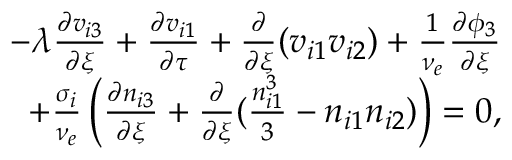Convert formula to latex. <formula><loc_0><loc_0><loc_500><loc_500>\begin{array} { r } { - \lambda \frac { \partial v _ { i 3 } } { \partial \xi } + \frac { \partial v _ { i 1 } } { \partial \tau } + \frac { \partial } { \partial \xi } ( v _ { i 1 } v _ { i 2 } ) + \frac { 1 } { \nu _ { e } } \frac { \partial \phi _ { 3 } } { \partial \xi } } \\ { + \frac { \sigma _ { i } } { \nu _ { e } } \left ( \frac { \partial n _ { i 3 } } { \partial \xi } + \frac { \partial } { \partial \xi } ( \frac { n _ { i 1 } ^ { 3 } } { 3 } - n _ { i 1 } n _ { i 2 } ) \right ) = 0 , } \end{array}</formula> 